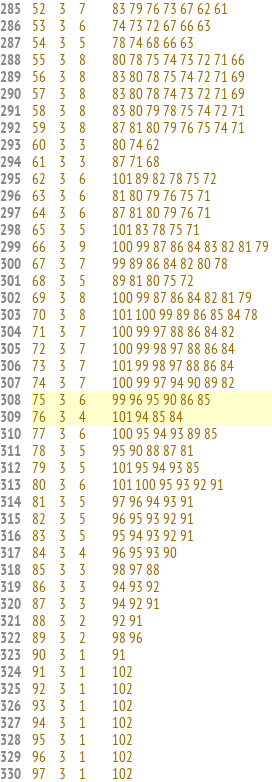Convert code to text. <code><loc_0><loc_0><loc_500><loc_500><_ObjectiveC_>52	3	7		83 79 76 73 67 62 61 
53	3	6		74 73 72 67 66 63 
54	3	5		78 74 68 66 63 
55	3	8		80 78 75 74 73 72 71 66 
56	3	8		83 80 78 75 74 72 71 69 
57	3	8		83 80 78 74 73 72 71 69 
58	3	8		83 80 79 78 75 74 72 71 
59	3	8		87 81 80 79 76 75 74 71 
60	3	3		80 74 62 
61	3	3		87 71 68 
62	3	6		101 89 82 78 75 72 
63	3	6		81 80 79 76 75 71 
64	3	6		87 81 80 79 76 71 
65	3	5		101 83 78 75 71 
66	3	9		100 99 87 86 84 83 82 81 79 
67	3	7		99 89 86 84 82 80 78 
68	3	5		89 81 80 75 72 
69	3	8		100 99 87 86 84 82 81 79 
70	3	8		101 100 99 89 86 85 84 78 
71	3	7		100 99 97 88 86 84 82 
72	3	7		100 99 98 97 88 86 84 
73	3	7		101 99 98 97 88 86 84 
74	3	7		100 99 97 94 90 89 82 
75	3	6		99 96 95 90 86 85 
76	3	4		101 94 85 84 
77	3	6		100 95 94 93 89 85 
78	3	5		95 90 88 87 81 
79	3	5		101 95 94 93 85 
80	3	6		101 100 95 93 92 91 
81	3	5		97 96 94 93 91 
82	3	5		96 95 93 92 91 
83	3	5		95 94 93 92 91 
84	3	4		96 95 93 90 
85	3	3		98 97 88 
86	3	3		94 93 92 
87	3	3		94 92 91 
88	3	2		92 91 
89	3	2		98 96 
90	3	1		91 
91	3	1		102 
92	3	1		102 
93	3	1		102 
94	3	1		102 
95	3	1		102 
96	3	1		102 
97	3	1		102 </code> 